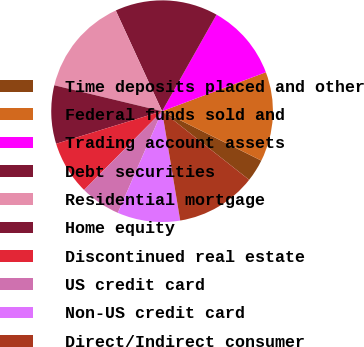<chart> <loc_0><loc_0><loc_500><loc_500><pie_chart><fcel>Time deposits placed and other<fcel>Federal funds sold and<fcel>Trading account assets<fcel>Debt securities<fcel>Residential mortgage<fcel>Home equity<fcel>Discontinued real estate<fcel>US credit card<fcel>Non-US credit card<fcel>Direct/Indirect consumer<nl><fcel>3.27%<fcel>13.07%<fcel>11.11%<fcel>15.03%<fcel>14.38%<fcel>8.5%<fcel>7.84%<fcel>5.88%<fcel>9.15%<fcel>11.76%<nl></chart> 